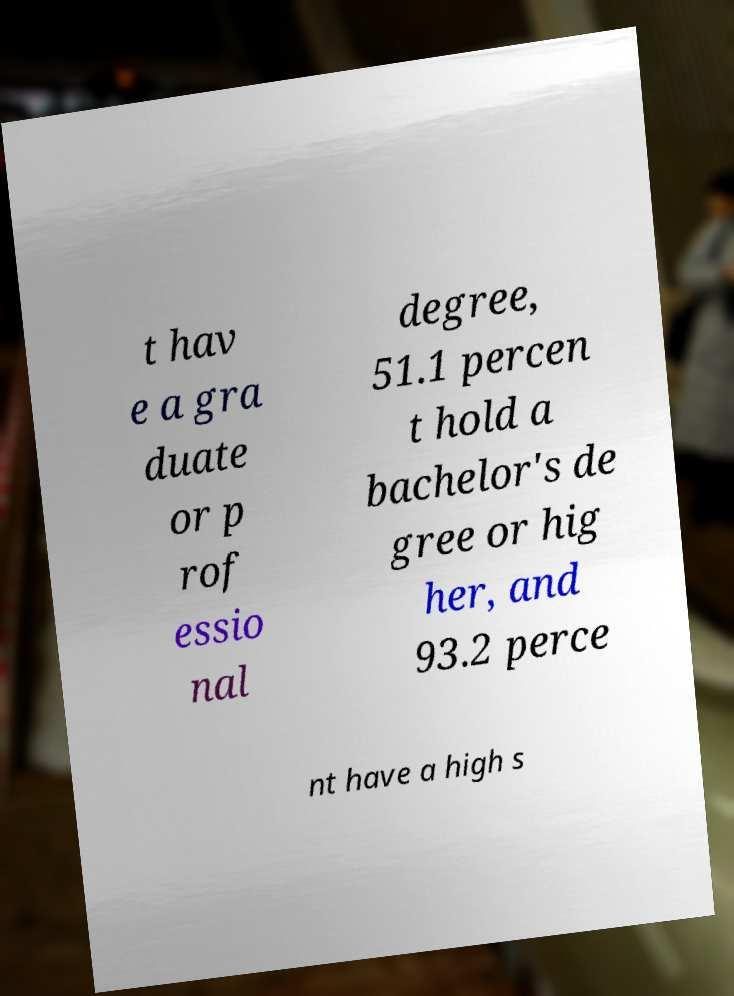Could you assist in decoding the text presented in this image and type it out clearly? t hav e a gra duate or p rof essio nal degree, 51.1 percen t hold a bachelor's de gree or hig her, and 93.2 perce nt have a high s 